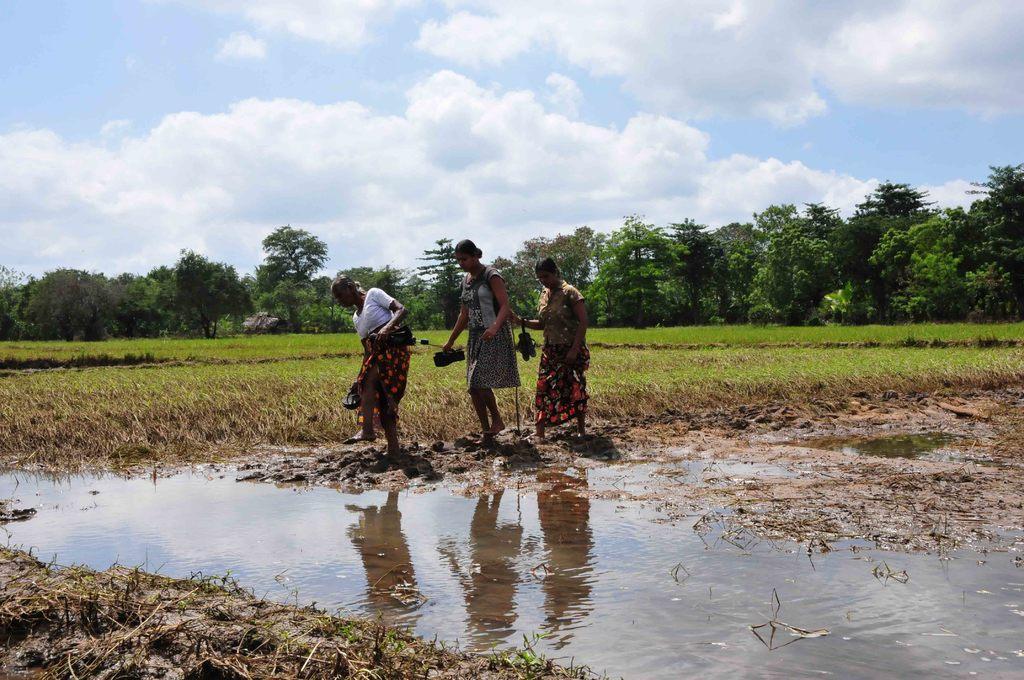Please provide a concise description of this image. Here we can see three women carrying foot wear in their hand and here we can see water. In the background there are trees and clouds in the sky. 